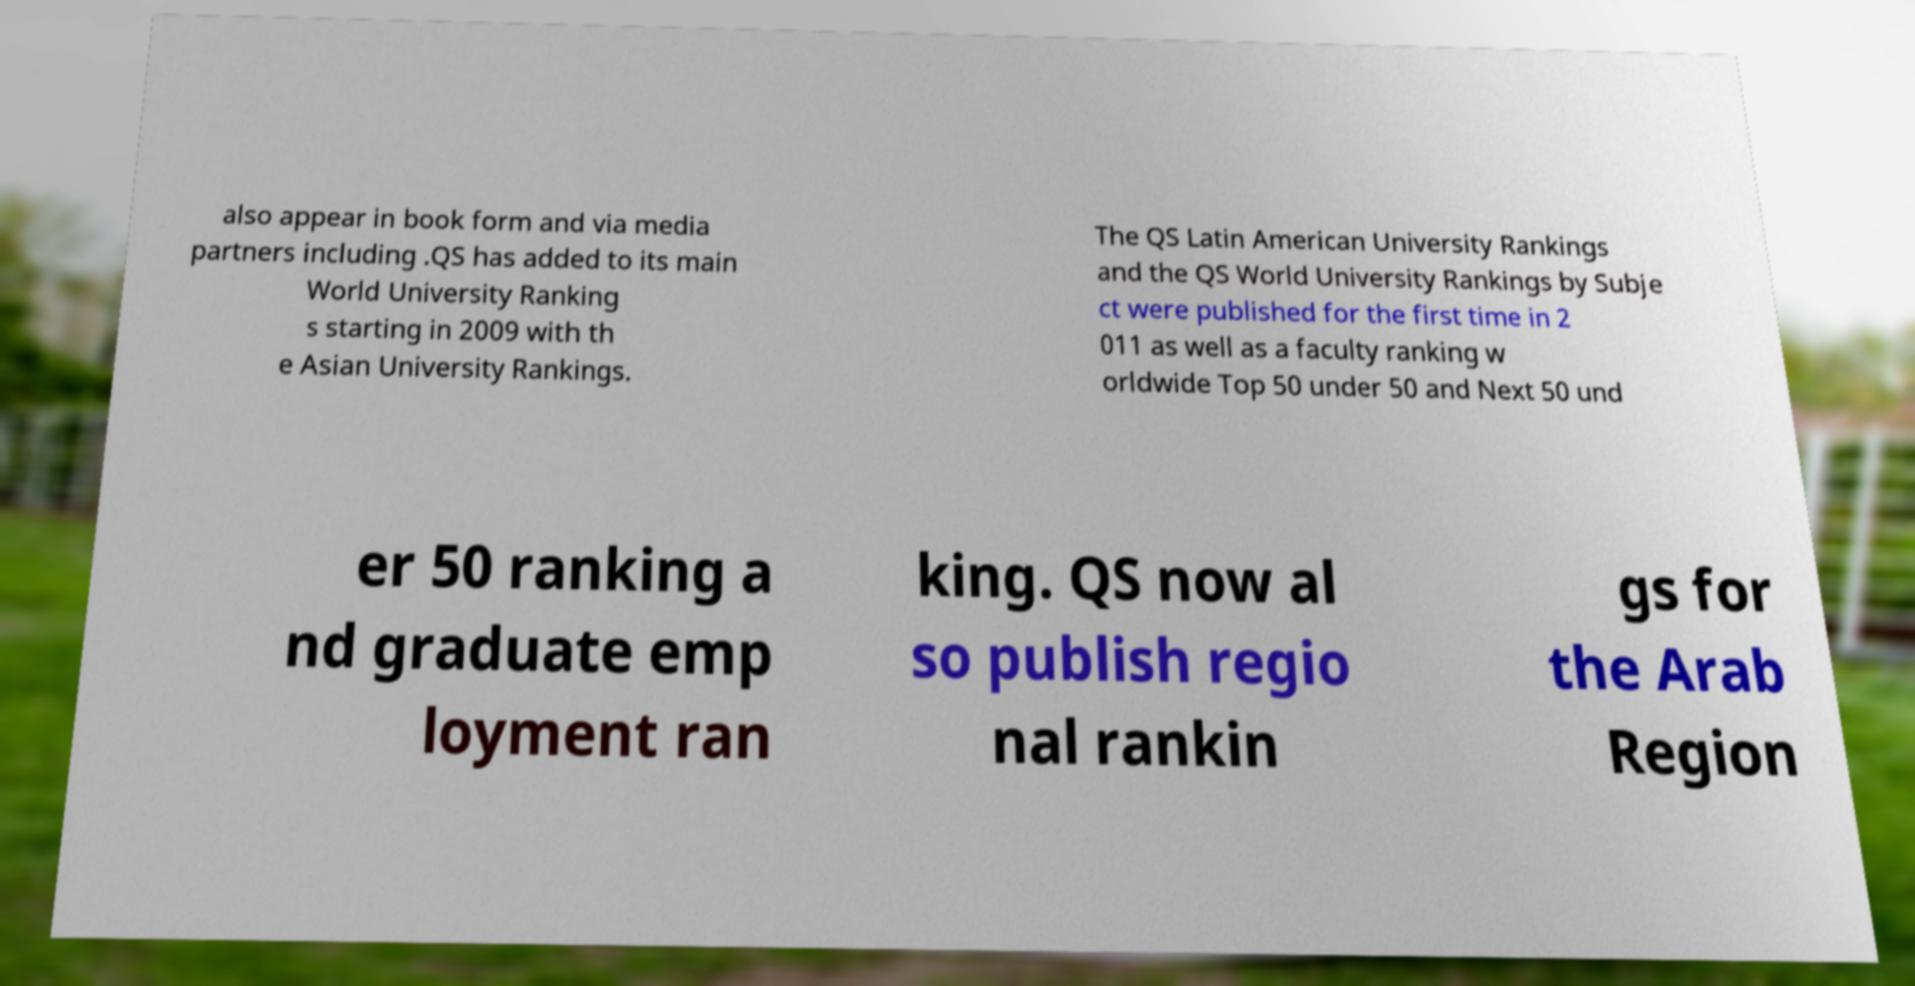I need the written content from this picture converted into text. Can you do that? also appear in book form and via media partners including .QS has added to its main World University Ranking s starting in 2009 with th e Asian University Rankings. The QS Latin American University Rankings and the QS World University Rankings by Subje ct were published for the first time in 2 011 as well as a faculty ranking w orldwide Top 50 under 50 and Next 50 und er 50 ranking a nd graduate emp loyment ran king. QS now al so publish regio nal rankin gs for the Arab Region 